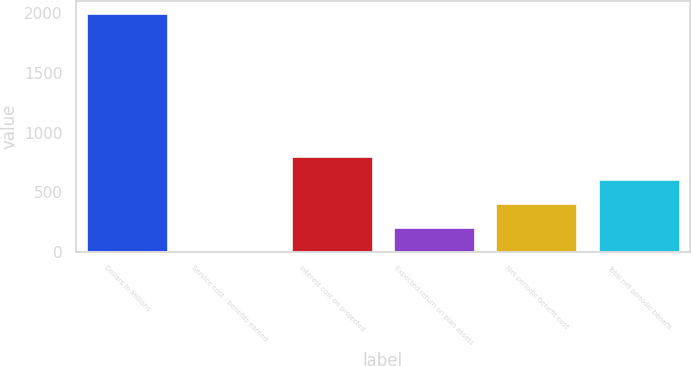Convert chart to OTSL. <chart><loc_0><loc_0><loc_500><loc_500><bar_chart><fcel>Dollars in Millions<fcel>Service cost - benefits earned<fcel>Interest cost on projected<fcel>Expected return on plan assets<fcel>Net periodic benefit cost<fcel>Total net periodic benefit<nl><fcel>2004<fcel>8<fcel>806.4<fcel>207.6<fcel>407.2<fcel>606.8<nl></chart> 